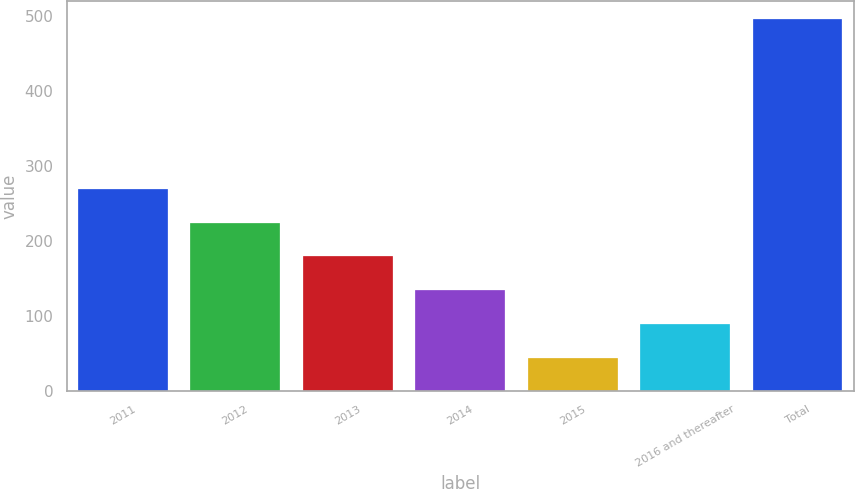Convert chart to OTSL. <chart><loc_0><loc_0><loc_500><loc_500><bar_chart><fcel>2011<fcel>2012<fcel>2013<fcel>2014<fcel>2015<fcel>2016 and thereafter<fcel>Total<nl><fcel>269.5<fcel>224.4<fcel>179.3<fcel>134.2<fcel>44<fcel>89.1<fcel>495<nl></chart> 